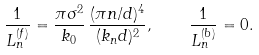<formula> <loc_0><loc_0><loc_500><loc_500>\frac { 1 } { L _ { n } ^ { ( f ) } } = \frac { \pi \sigma ^ { 2 } } { k _ { 0 } } \, \frac { ( \pi n / d ) ^ { 4 } } { ( k _ { n } d ) ^ { 2 } } , \quad \frac { 1 } { L _ { n } ^ { ( b ) } } = 0 .</formula> 